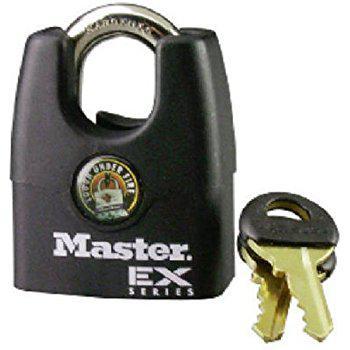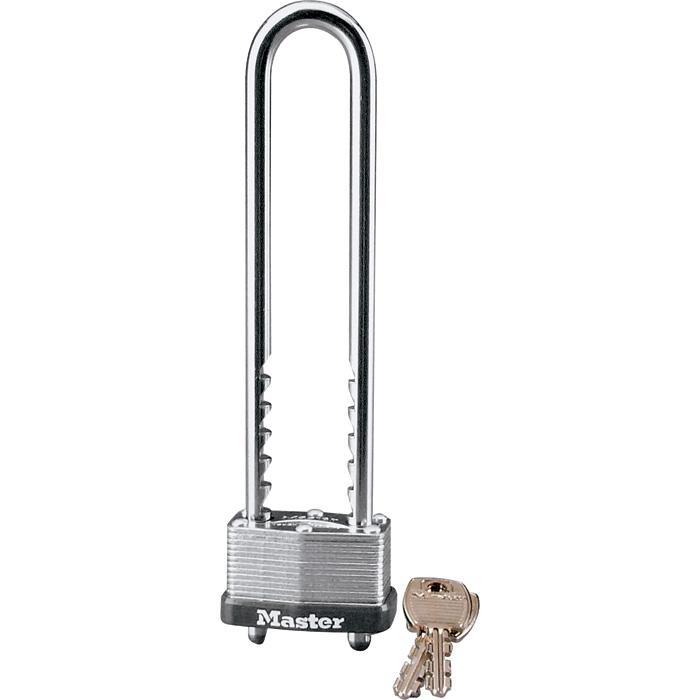The first image is the image on the left, the second image is the image on the right. Analyze the images presented: Is the assertion "There is a pair of gold colored keys beside a lock in one of the images." valid? Answer yes or no. Yes. The first image is the image on the left, the second image is the image on the right. Analyze the images presented: Is the assertion "there are two keys next to a lock" valid? Answer yes or no. Yes. 